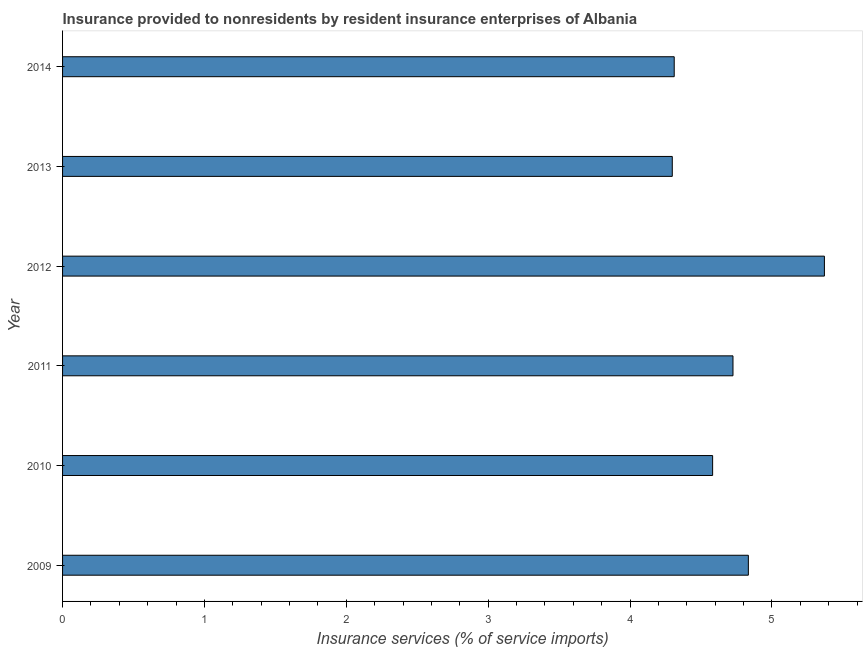Does the graph contain grids?
Your answer should be compact. No. What is the title of the graph?
Give a very brief answer. Insurance provided to nonresidents by resident insurance enterprises of Albania. What is the label or title of the X-axis?
Give a very brief answer. Insurance services (% of service imports). What is the insurance and financial services in 2013?
Your response must be concise. 4.3. Across all years, what is the maximum insurance and financial services?
Make the answer very short. 5.37. Across all years, what is the minimum insurance and financial services?
Your answer should be compact. 4.3. In which year was the insurance and financial services maximum?
Ensure brevity in your answer.  2012. In which year was the insurance and financial services minimum?
Your answer should be very brief. 2013. What is the sum of the insurance and financial services?
Make the answer very short. 28.12. What is the difference between the insurance and financial services in 2011 and 2013?
Keep it short and to the point. 0.43. What is the average insurance and financial services per year?
Your answer should be very brief. 4.69. What is the median insurance and financial services?
Offer a very short reply. 4.65. In how many years, is the insurance and financial services greater than 2.2 %?
Offer a terse response. 6. What is the ratio of the insurance and financial services in 2010 to that in 2013?
Provide a short and direct response. 1.07. Is the insurance and financial services in 2013 less than that in 2014?
Make the answer very short. Yes. What is the difference between the highest and the second highest insurance and financial services?
Provide a succinct answer. 0.54. Is the sum of the insurance and financial services in 2009 and 2010 greater than the maximum insurance and financial services across all years?
Provide a short and direct response. Yes. What is the difference between the highest and the lowest insurance and financial services?
Your answer should be very brief. 1.07. In how many years, is the insurance and financial services greater than the average insurance and financial services taken over all years?
Make the answer very short. 3. How many bars are there?
Your response must be concise. 6. Are the values on the major ticks of X-axis written in scientific E-notation?
Ensure brevity in your answer.  No. What is the Insurance services (% of service imports) in 2009?
Ensure brevity in your answer.  4.83. What is the Insurance services (% of service imports) in 2010?
Give a very brief answer. 4.58. What is the Insurance services (% of service imports) in 2011?
Keep it short and to the point. 4.73. What is the Insurance services (% of service imports) of 2012?
Make the answer very short. 5.37. What is the Insurance services (% of service imports) of 2013?
Ensure brevity in your answer.  4.3. What is the Insurance services (% of service imports) of 2014?
Offer a very short reply. 4.31. What is the difference between the Insurance services (% of service imports) in 2009 and 2010?
Offer a very short reply. 0.25. What is the difference between the Insurance services (% of service imports) in 2009 and 2011?
Offer a very short reply. 0.11. What is the difference between the Insurance services (% of service imports) in 2009 and 2012?
Provide a succinct answer. -0.54. What is the difference between the Insurance services (% of service imports) in 2009 and 2013?
Provide a succinct answer. 0.54. What is the difference between the Insurance services (% of service imports) in 2009 and 2014?
Keep it short and to the point. 0.52. What is the difference between the Insurance services (% of service imports) in 2010 and 2011?
Keep it short and to the point. -0.14. What is the difference between the Insurance services (% of service imports) in 2010 and 2012?
Ensure brevity in your answer.  -0.79. What is the difference between the Insurance services (% of service imports) in 2010 and 2013?
Offer a very short reply. 0.28. What is the difference between the Insurance services (% of service imports) in 2010 and 2014?
Offer a very short reply. 0.27. What is the difference between the Insurance services (% of service imports) in 2011 and 2012?
Your answer should be very brief. -0.64. What is the difference between the Insurance services (% of service imports) in 2011 and 2013?
Offer a terse response. 0.43. What is the difference between the Insurance services (% of service imports) in 2011 and 2014?
Keep it short and to the point. 0.41. What is the difference between the Insurance services (% of service imports) in 2012 and 2013?
Make the answer very short. 1.07. What is the difference between the Insurance services (% of service imports) in 2012 and 2014?
Ensure brevity in your answer.  1.06. What is the difference between the Insurance services (% of service imports) in 2013 and 2014?
Your answer should be very brief. -0.01. What is the ratio of the Insurance services (% of service imports) in 2009 to that in 2010?
Your response must be concise. 1.05. What is the ratio of the Insurance services (% of service imports) in 2009 to that in 2013?
Provide a succinct answer. 1.12. What is the ratio of the Insurance services (% of service imports) in 2009 to that in 2014?
Give a very brief answer. 1.12. What is the ratio of the Insurance services (% of service imports) in 2010 to that in 2011?
Ensure brevity in your answer.  0.97. What is the ratio of the Insurance services (% of service imports) in 2010 to that in 2012?
Give a very brief answer. 0.85. What is the ratio of the Insurance services (% of service imports) in 2010 to that in 2013?
Your answer should be very brief. 1.07. What is the ratio of the Insurance services (% of service imports) in 2010 to that in 2014?
Keep it short and to the point. 1.06. What is the ratio of the Insurance services (% of service imports) in 2011 to that in 2014?
Make the answer very short. 1.1. What is the ratio of the Insurance services (% of service imports) in 2012 to that in 2013?
Make the answer very short. 1.25. What is the ratio of the Insurance services (% of service imports) in 2012 to that in 2014?
Give a very brief answer. 1.25. 